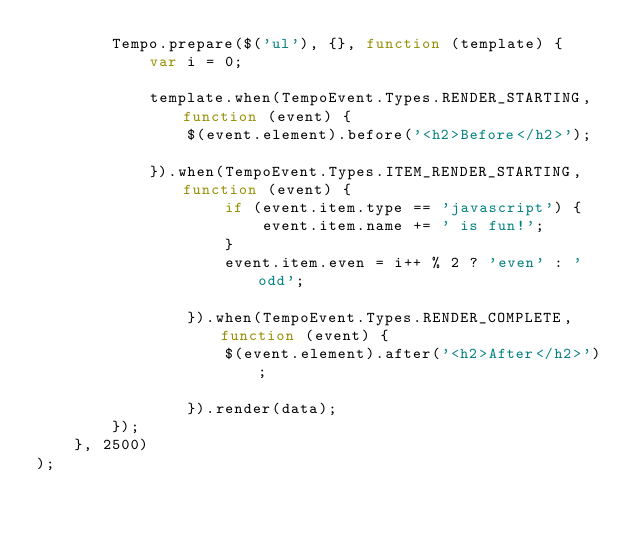Convert code to text. <code><loc_0><loc_0><loc_500><loc_500><_JavaScript_>        Tempo.prepare($('ul'), {}, function (template) {
            var i = 0;

            template.when(TempoEvent.Types.RENDER_STARTING,function (event) {
                $(event.element).before('<h2>Before</h2>');

            }).when(TempoEvent.Types.ITEM_RENDER_STARTING,function (event) {
                    if (event.item.type == 'javascript') {
                        event.item.name += ' is fun!';
                    }
                    event.item.even = i++ % 2 ? 'even' : 'odd';

                }).when(TempoEvent.Types.RENDER_COMPLETE,function (event) {
                    $(event.element).after('<h2>After</h2>');

                }).render(data);
        });
    }, 2500)
);</code> 